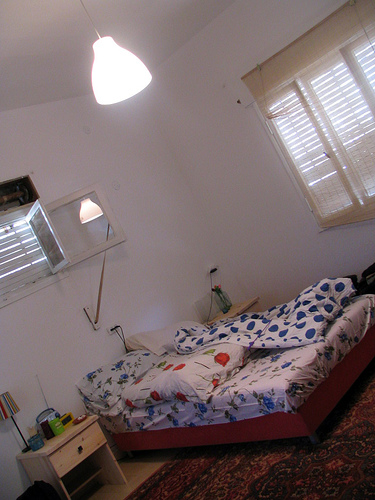<image>Who photographed the bedroom? It is unknown who photographed the bedroom. It could be anyone from a photographer to a real estate agent, a homeowner, or a renter. Who photographed the bedroom? I don't know who photographed the bedroom. It can be either the parents, me, the photographer, the renter, the homeowner, or the real estate agent. 